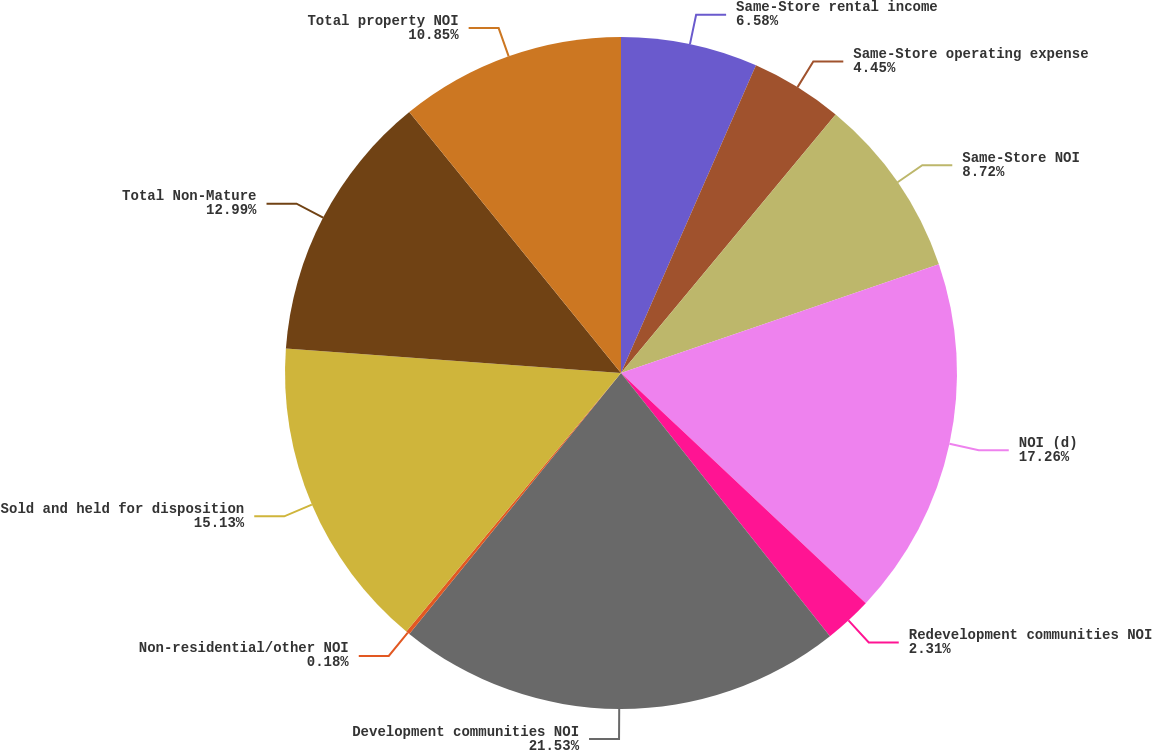Convert chart to OTSL. <chart><loc_0><loc_0><loc_500><loc_500><pie_chart><fcel>Same-Store rental income<fcel>Same-Store operating expense<fcel>Same-Store NOI<fcel>NOI (d)<fcel>Redevelopment communities NOI<fcel>Development communities NOI<fcel>Non-residential/other NOI<fcel>Sold and held for disposition<fcel>Total Non-Mature<fcel>Total property NOI<nl><fcel>6.58%<fcel>4.45%<fcel>8.72%<fcel>17.26%<fcel>2.31%<fcel>21.53%<fcel>0.18%<fcel>15.13%<fcel>12.99%<fcel>10.85%<nl></chart> 